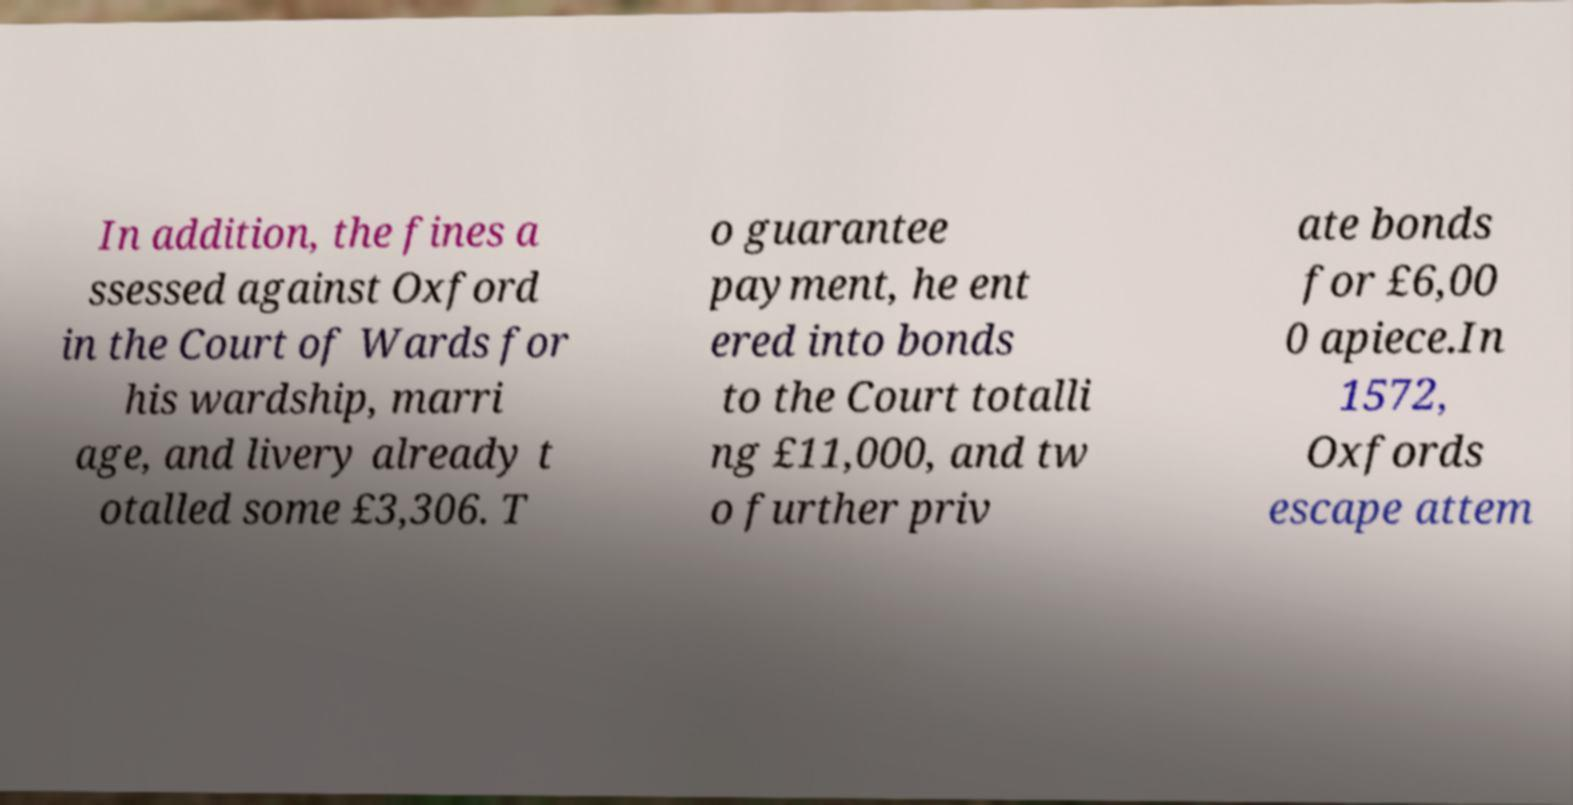There's text embedded in this image that I need extracted. Can you transcribe it verbatim? In addition, the fines a ssessed against Oxford in the Court of Wards for his wardship, marri age, and livery already t otalled some £3,306. T o guarantee payment, he ent ered into bonds to the Court totalli ng £11,000, and tw o further priv ate bonds for £6,00 0 apiece.In 1572, Oxfords escape attem 